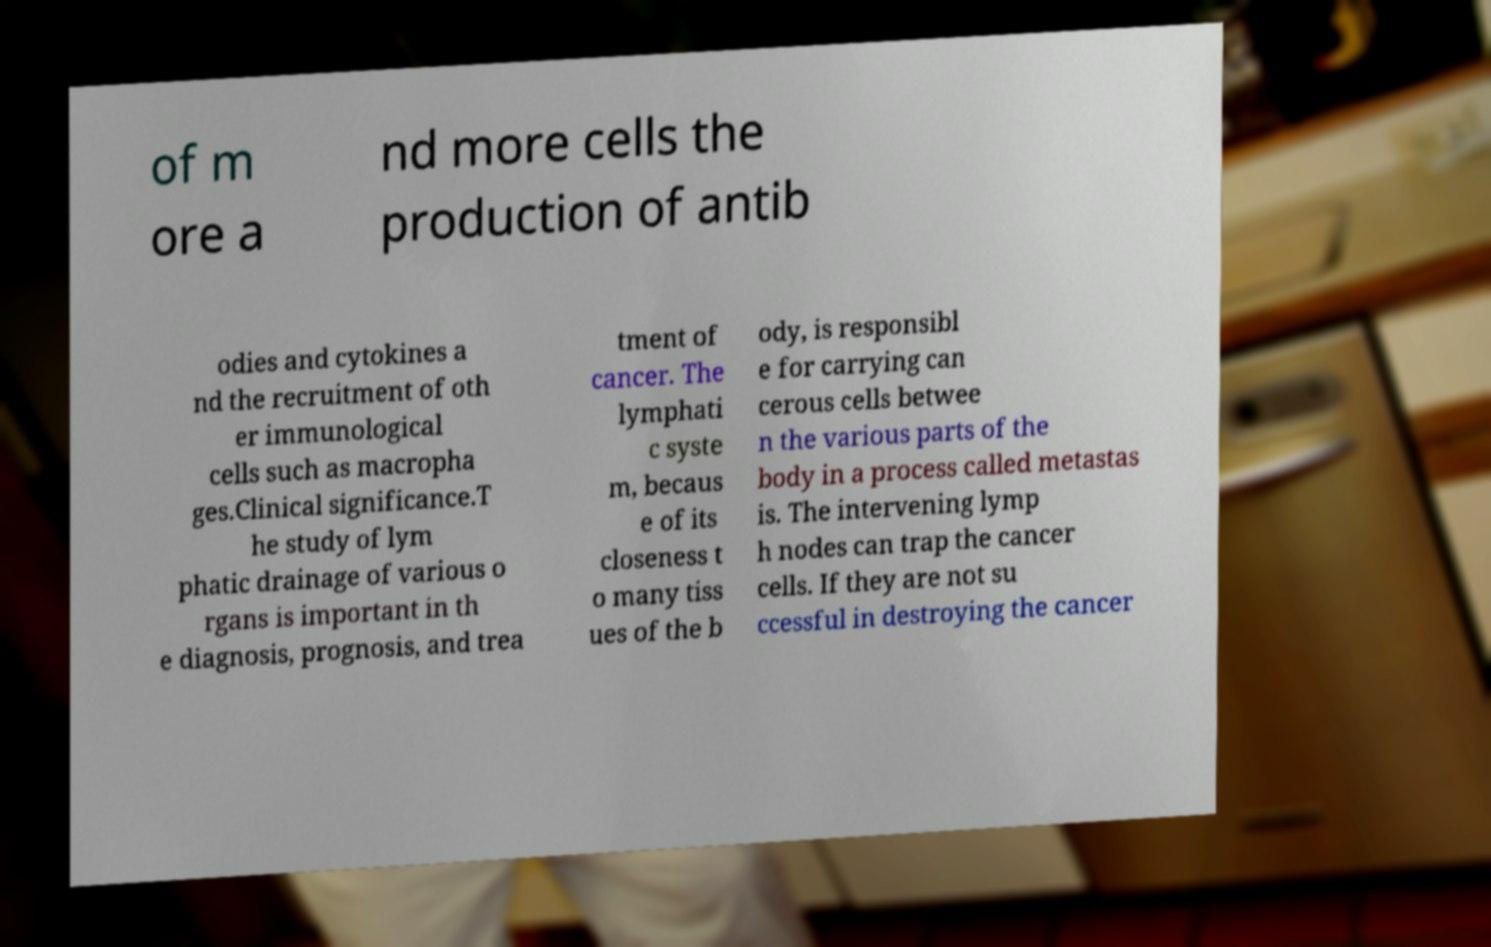Please read and relay the text visible in this image. What does it say? of m ore a nd more cells the production of antib odies and cytokines a nd the recruitment of oth er immunological cells such as macropha ges.Clinical significance.T he study of lym phatic drainage of various o rgans is important in th e diagnosis, prognosis, and trea tment of cancer. The lymphati c syste m, becaus e of its closeness t o many tiss ues of the b ody, is responsibl e for carrying can cerous cells betwee n the various parts of the body in a process called metastas is. The intervening lymp h nodes can trap the cancer cells. If they are not su ccessful in destroying the cancer 